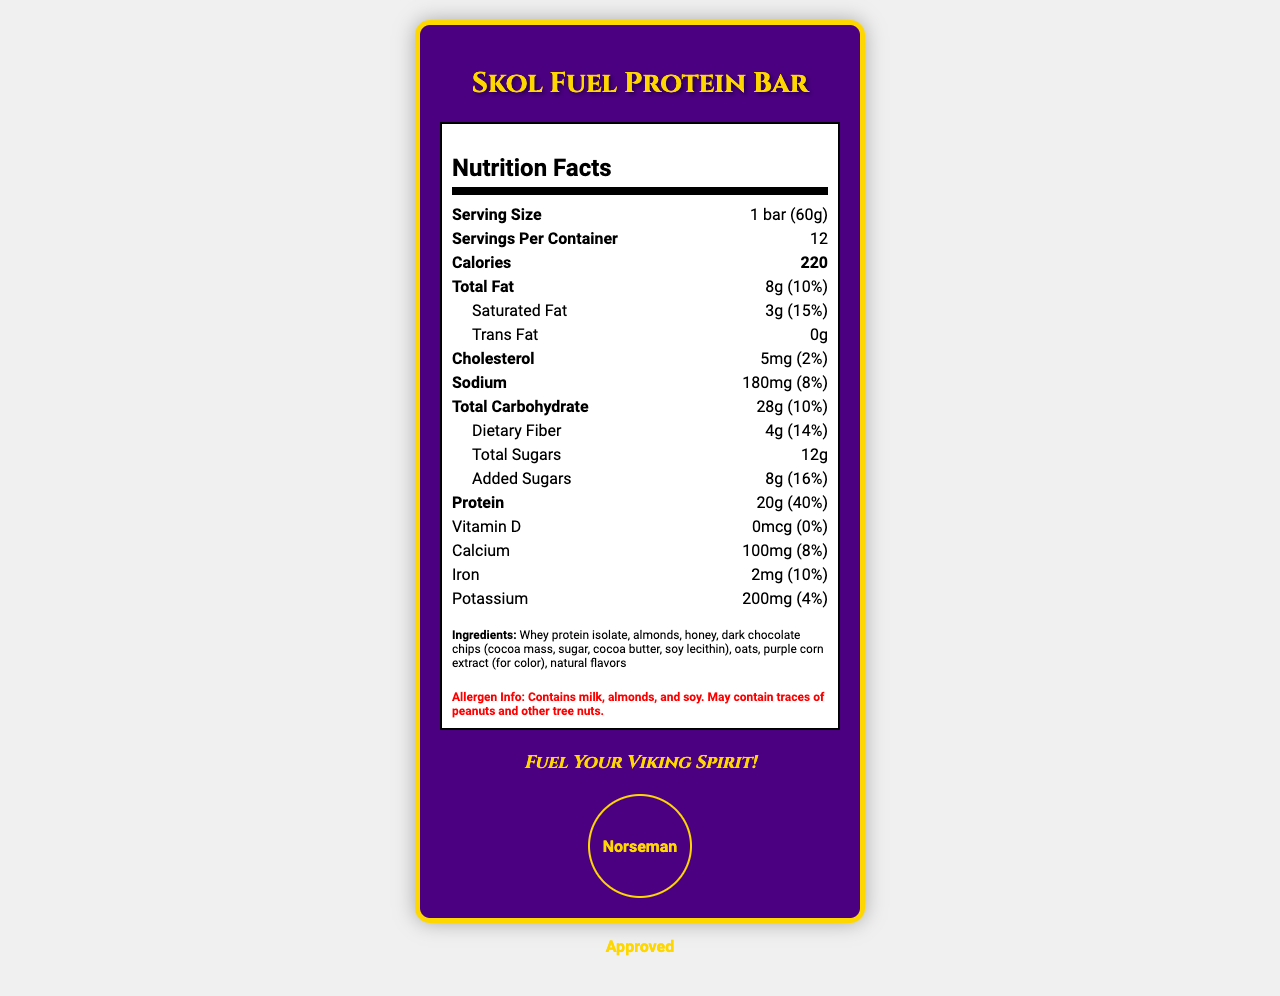what is the product name? The document title and the header clearly state "Skol Fuel Protein Bar".
Answer: Skol Fuel Protein Bar what is the serving size? The serving size is listed under the "Serving Size" section in the nutrition facts.
Answer: 1 bar (60g) how many servings are there per container? The number of servings per container is stated as 12 under the "Servings Per Container" section.
Answer: 12 how many calories does one bar have? It is clearly written in the "Calories" section that each serving has 220 calories.
Answer: 220 what is the total amount of fat in one bar? The "Total Fat" section lists 8g as the total amount of fat in one serving.
Answer: 8g what allergens are present in the Skol Fuel Protein Bar? The "Allergen Info" section states these allergens are present.
Answer: Milk, almonds, and soy what is the percentage of daily value for protein in one bar? A. 20% B. 30% C. 40% D. 50% The document lists the "Protein" section with a daily value of 40%.
Answer: C. 40% which vitamin or mineral has the highest daily value percentage? A. Calcium B. Iron C. Potassium The calcium daily value is 8%, which is the highest among the options given.
Answer: A. Calcium is the Skol Fuel Protein Bar "Norseman Approved"? This is explicitly stated within the "Norseman Approved" seal in the document.
Answer: Yes summarize the main idea of the Skol Fuel Protein Bar Nutrition Facts label. The document summarizes the nutritional content and branding aspects of the Skol Fuel Protein Bar, emphasizing its connection to the Vikings and its suitability for fans.
Answer: The document provides detailed nutrition information about the Skol Fuel Protein Bar, including macronutrient content, vitamin and mineral percentages, and allergen information. It highlights key features such as being a Vikings-themed product, is exclusive to US Bank Stadium, and features tailgate-friendly attributes. The bar contains 220 calories, 20g of protein, and important information like the presence of milk, almonds, and soy allergens. It combines elements that promote the Viking spirit with a clear focus on nutritional content. which ingredient is listed first, indicating it's the most abundant by weight? Ingredients are listed by weight, and "whey protein isolate" is the first ingredient mentioned.
Answer: Whey protein isolate is there a significant amount of Vitamin D in one bar of the Skol Fuel Protein Bar? The document shows 0% daily value for Vitamin D.
Answer: No can the document help determine the Skol Fuel Protein Bar's price? The document contains detailed nutritional and allergen information but does not mention the price of the protein bar.
Answer: Cannot be determined 